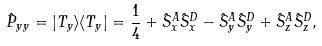<formula> <loc_0><loc_0><loc_500><loc_500>\hat { P } _ { y y } = | T _ { y } \rangle \langle T _ { y } | = \frac { 1 } { 4 } + \hat { S } _ { x } ^ { A } \hat { S } _ { x } ^ { D } - \hat { S } _ { y } ^ { A } \hat { S } _ { y } ^ { D } + \hat { S } _ { z } ^ { A } \hat { S } _ { z } ^ { D } ,</formula> 